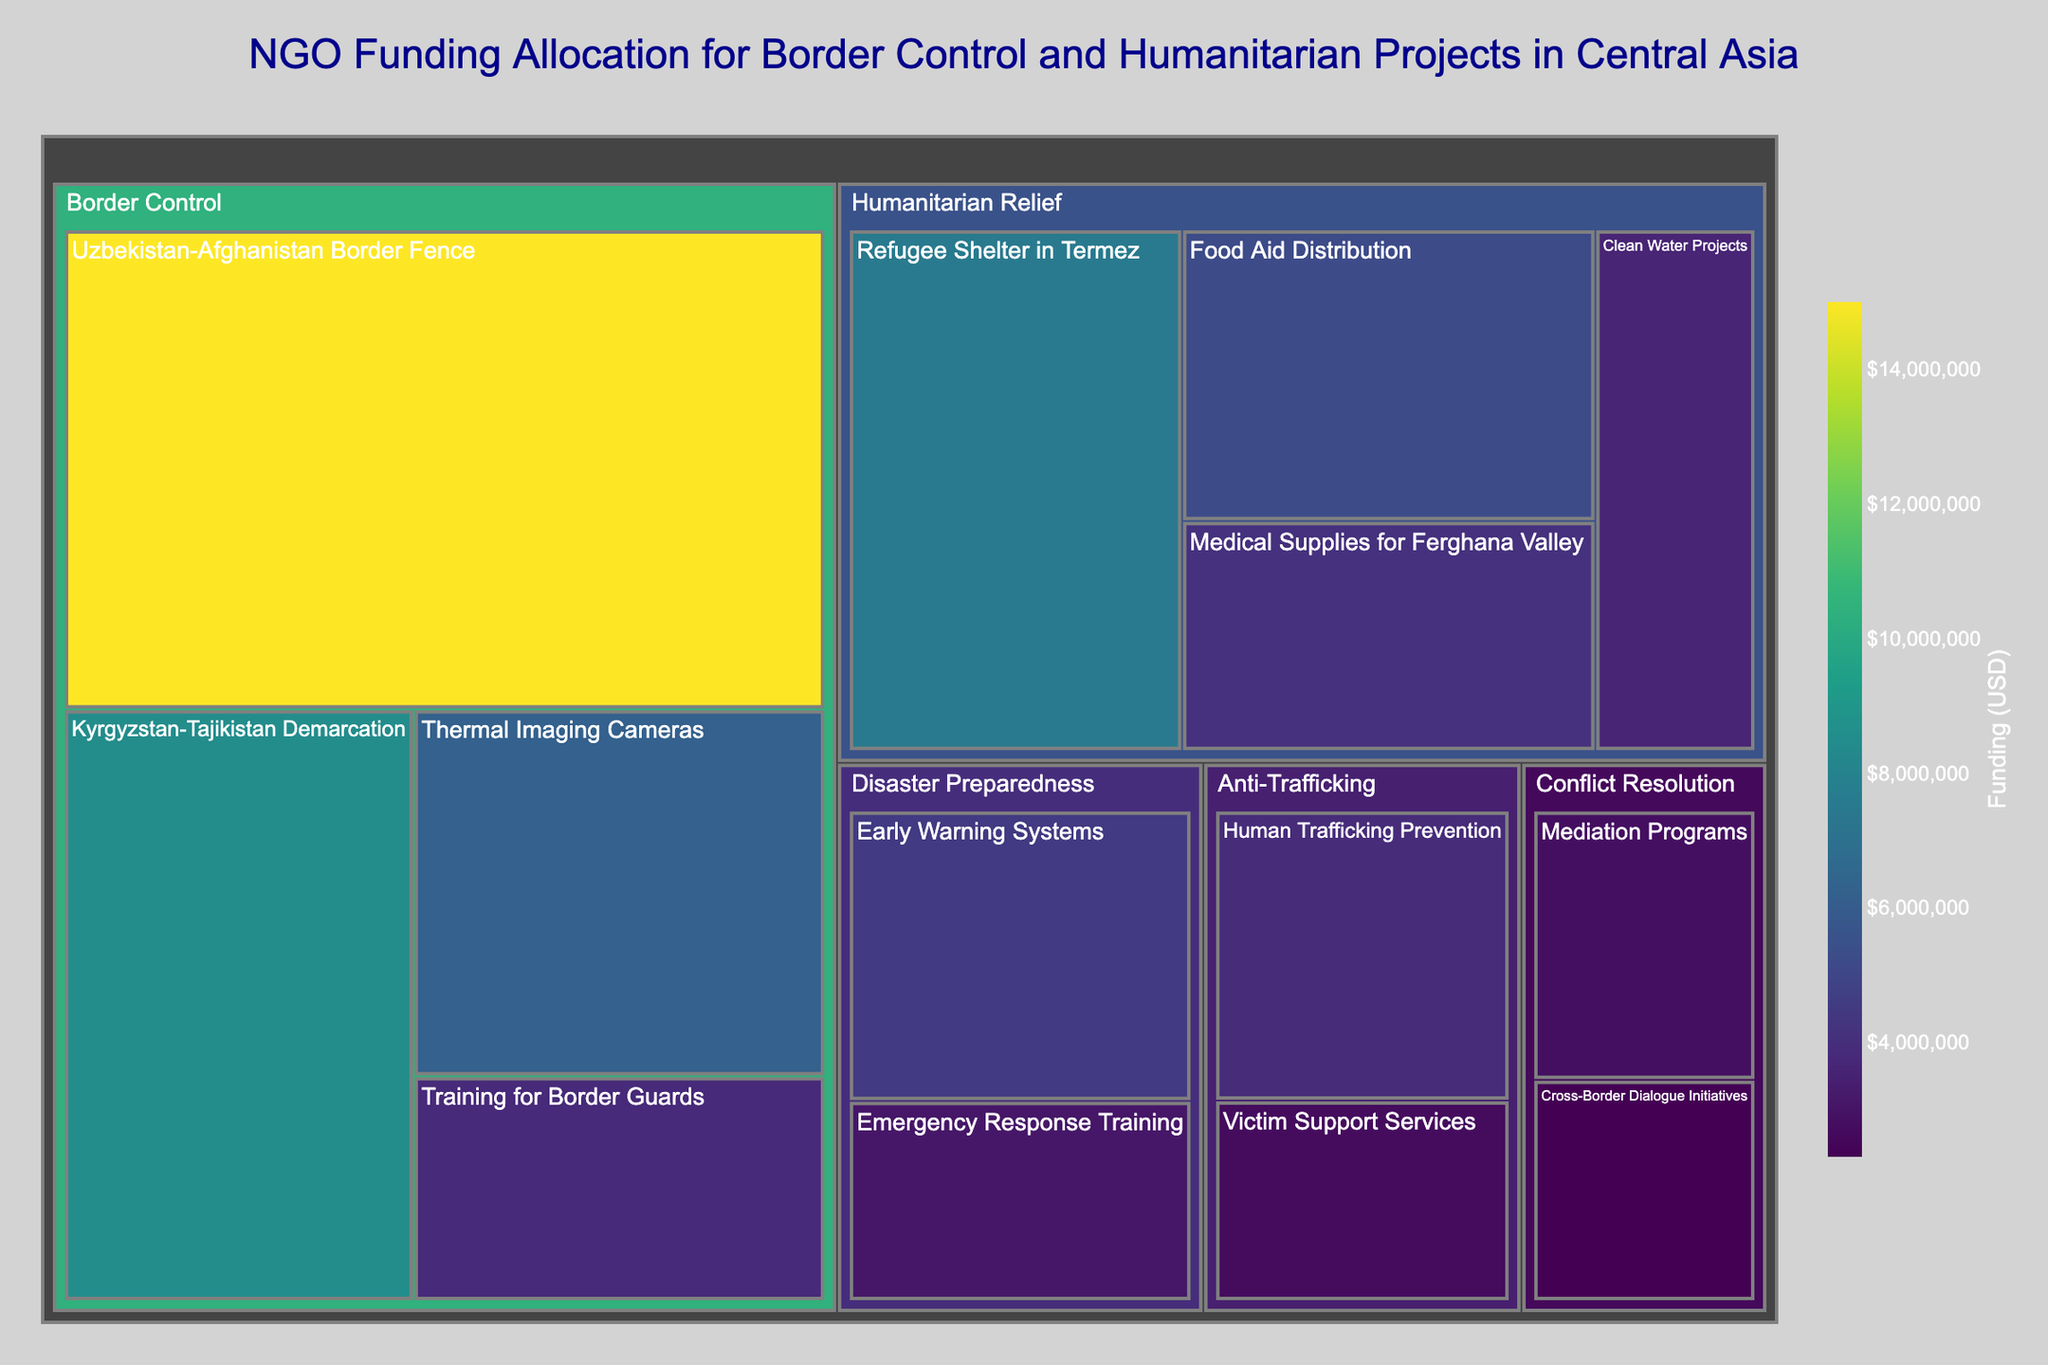What is the title of the plot? The title of the plot is usually displayed prominently at the top of the figure. In this case, it reads "NGO Funding Allocation for Border Control and Humanitarian Projects in Central Asia."
Answer: NGO Funding Allocation for Border Control and Humanitarian Projects in Central Asia Which subcategory received the highest amount of funding? By looking at the largest segment in the treemap, we see that "Uzbekistan-Afghanistan Border Fence" under the "Border Control" category received the highest funding amount.
Answer: Uzbekistan-Afghanistan Border Fence What is the combined funding amount for the "Humanitarian Relief" category? By summing the funding amounts for all subcategories under "Humanitarian Relief": 7,500,000 (Refugee Shelter in Termez) + 5,200,000 (Food Aid Distribution) + 4,100,000 (Medical Supplies for Ferghana Valley) + 3,600,000 (Clean Water Projects), we get a total of 20,400,000 USD.
Answer: 20,400,000 USD Which categories have the smallest and largest funding amounts? By comparing the size of each category's segments, the "Border Control" category has the largest funding (with segments like Uzbekistan-Afghanistan Border Fence) while "Conflict Resolution" has the smallest funding.
Answer: Border Control (largest) and Conflict Resolution (smallest) Which project has more funding: “Thermal Imaging Cameras” or “Training for Border Guards”? By comparing the sizes of the two segments under "Border Control," "Thermal Imaging Cameras" with 6,200,000 USD has more funding than "Training for Border Guards" with 3,800,000 USD.
Answer: Thermal Imaging Cameras What is the total funding allocated to “Disaster Preparedness” projects? By summing the values under "Disaster Preparedness": 4,500,000 (Early Warning Systems) + 3,100,000 (Emergency Response Training), we get a total of 7,600,000 USD.
Answer: 7,600,000 USD How much more funding does "Human Trafficking Prevention" have compared to "Victim Support Services"? Subtract the funding for "Victim Support Services" from "Human Trafficking Prevention": 3,900,000 - 2,700,000 = 1,200,000 USD.
Answer: 1,200,000 USD What are the total funding amounts allocated to "Anti-Trafficking" and "Conflict Resolution" combined? By adding the total funding in each category: (3,900,000 + 2,700,000) for "Anti-Trafficking" + (2,800,000 + 2,300,000) for "Conflict Resolution," we get 6,600,000 + 5,100,000 = 11,700,000 USD.
Answer: 11,700,000 USD Which has a higher funding amount: "Medical Supplies for Ferghana Valley" or "Clean Water Projects"? By looking at the figures under "Humanitarian Relief," "Medical Supplies for Ferghana Valley" with 4,100,000 USD has higher funding than "Clean Water Projects" with 3,600,000 USD.
Answer: Medical Supplies for Ferghana Valley Which subcategory under "Disaster Preparedness" received the lowest funding? Looking at the two subcategories under "Disaster Preparedness," "Emergency Response Training" received the lowest funding with 3,100,000 USD compared to "Early Warning Systems."
Answer: Emergency Response Training 